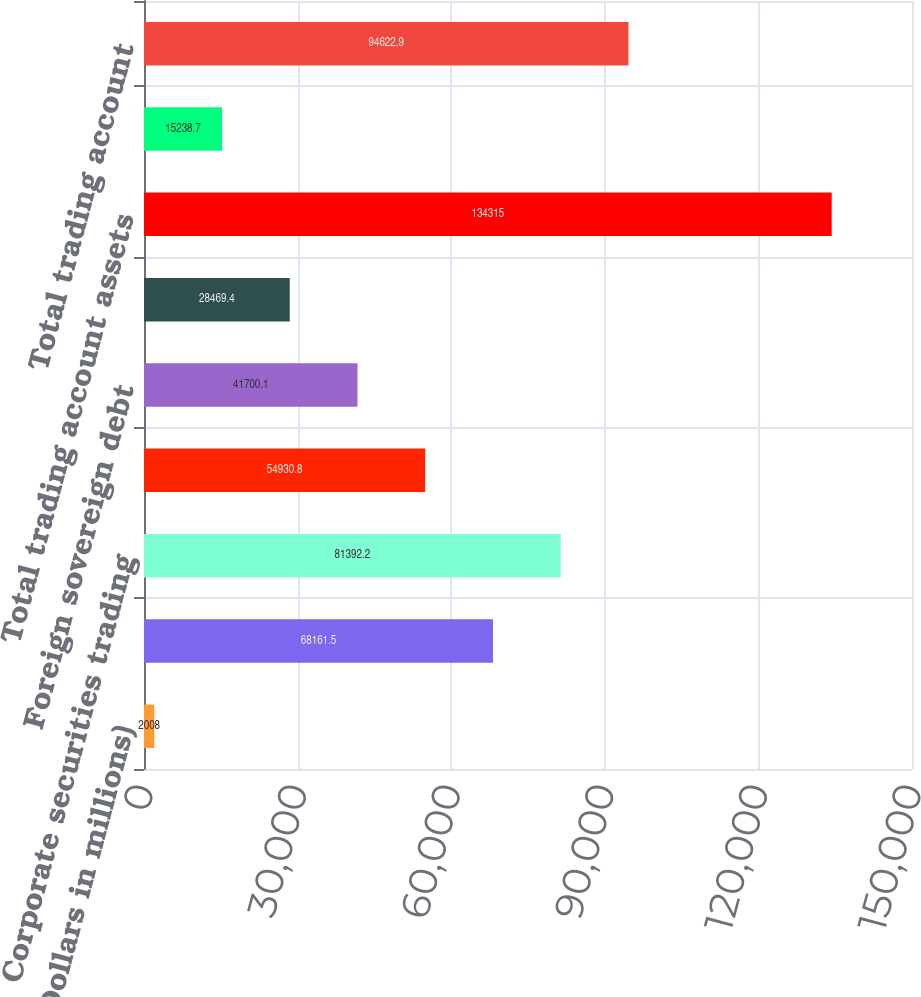Convert chart. <chart><loc_0><loc_0><loc_500><loc_500><bar_chart><fcel>(Dollars in millions)<fcel>US government and agency<fcel>Corporate securities trading<fcel>Equity securities<fcel>Foreign sovereign debt<fcel>Mortgage trading loans and<fcel>Total trading account assets<fcel>Corporate securities and other<fcel>Total trading account<nl><fcel>2008<fcel>68161.5<fcel>81392.2<fcel>54930.8<fcel>41700.1<fcel>28469.4<fcel>134315<fcel>15238.7<fcel>94622.9<nl></chart> 